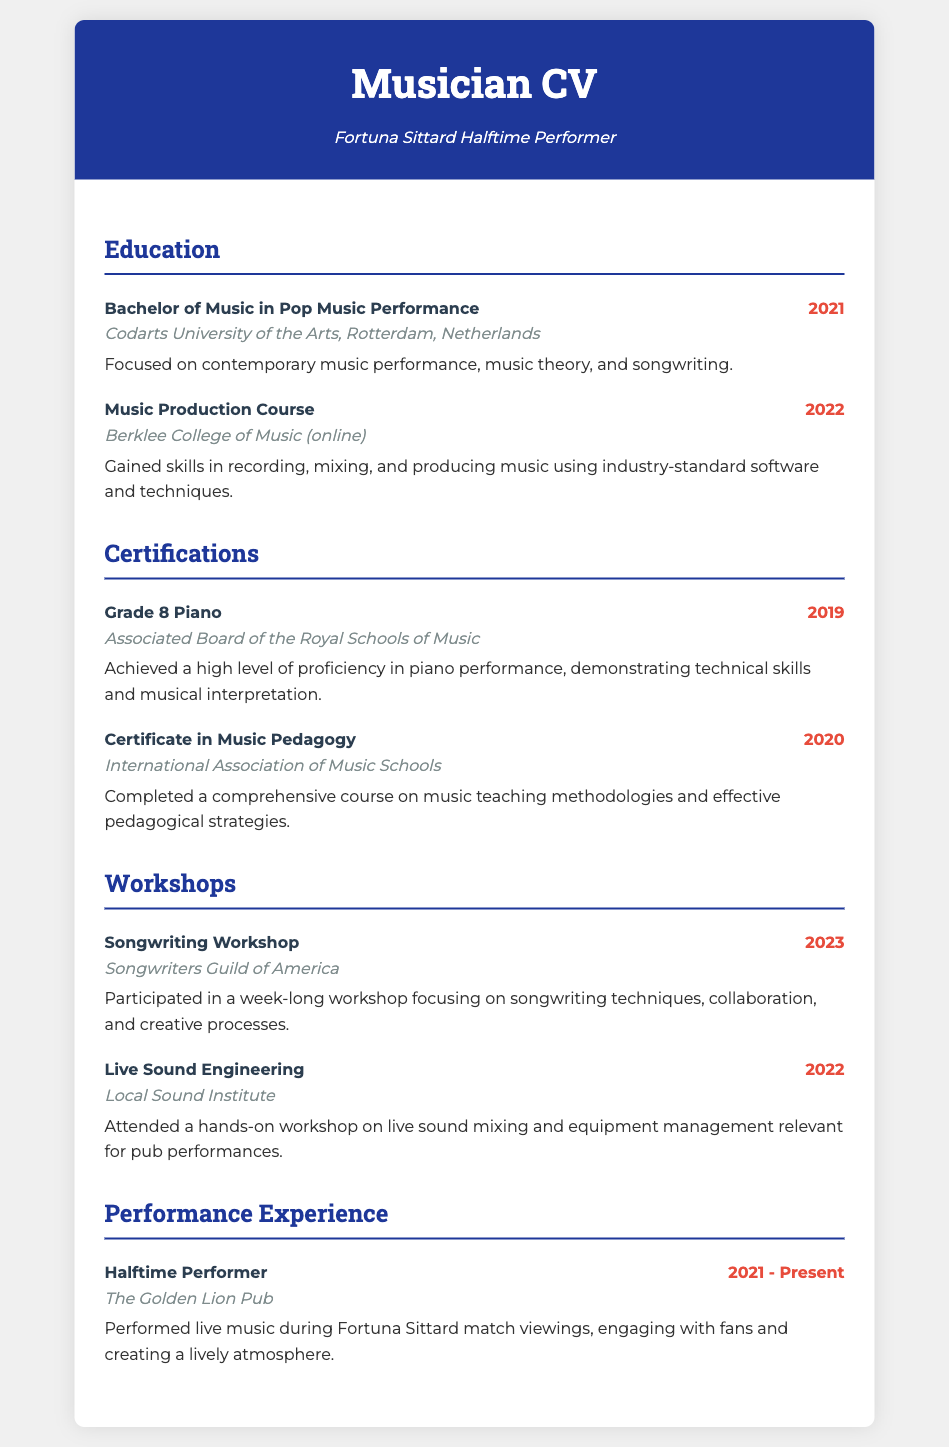What is the degree obtained? The degree is listed under the Education section in the CV, specifically in the first item where it states "Bachelor of Music in Pop Music Performance."
Answer: Bachelor of Music in Pop Music Performance Which university awarded the degree? The university is mentioned in the same item, indicating that it is Codarts University of the Arts.
Answer: Codarts University of the Arts How many certifications are listed? The Certifications section contains two items which represent the number of certifications achieved.
Answer: 2 What year was the Music Production Course completed? The year of completion is stated in the second item of the Education section, which shows "2022" next to the course title.
Answer: 2022 What type of workshop was attended in 2022? The workshop type is mentioned in the Workshops section where it refers to "Live Sound Engineering."
Answer: Live Sound Engineering In which year was the Grade 8 Piano certification earned? The year is clearly displayed in the first item of the Certifications section next to the certification title.
Answer: 2019 What is the total number of performances listed? The performance experience is detailed in one item under the Performance Experience section, indicating the number of performances.
Answer: 1 What is the subtitle of the document? The subtitle is presented directly below the main title, indicating the focus of the musician.
Answer: Fortuna Sittard Halftime Performer 